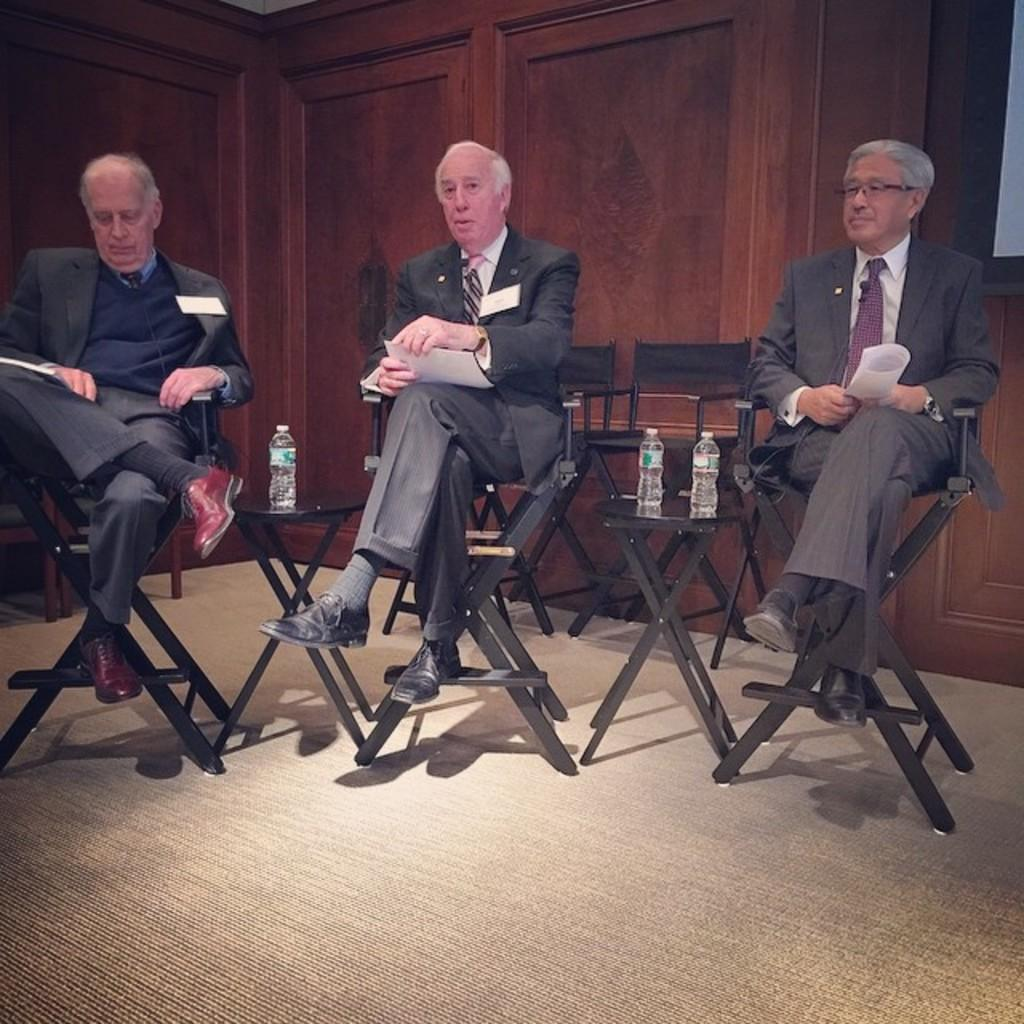How many people are in the image? There are three persons in the image. What are the persons doing in the image? The persons are sitting on chairs and holding papers. What objects can be seen on the tables in the image? There are bottles on the tables. What type of clothing are the three men wearing? The three men are wearing suits and shoes. What type of ground can be seen beneath the chairs in the image? There is no ground visible beneath the chairs in the image; it appears to be an indoor setting. Can you tell me how many veins are present in the image? There are no veins present in the image; it features three men sitting on chairs and holding papers. 